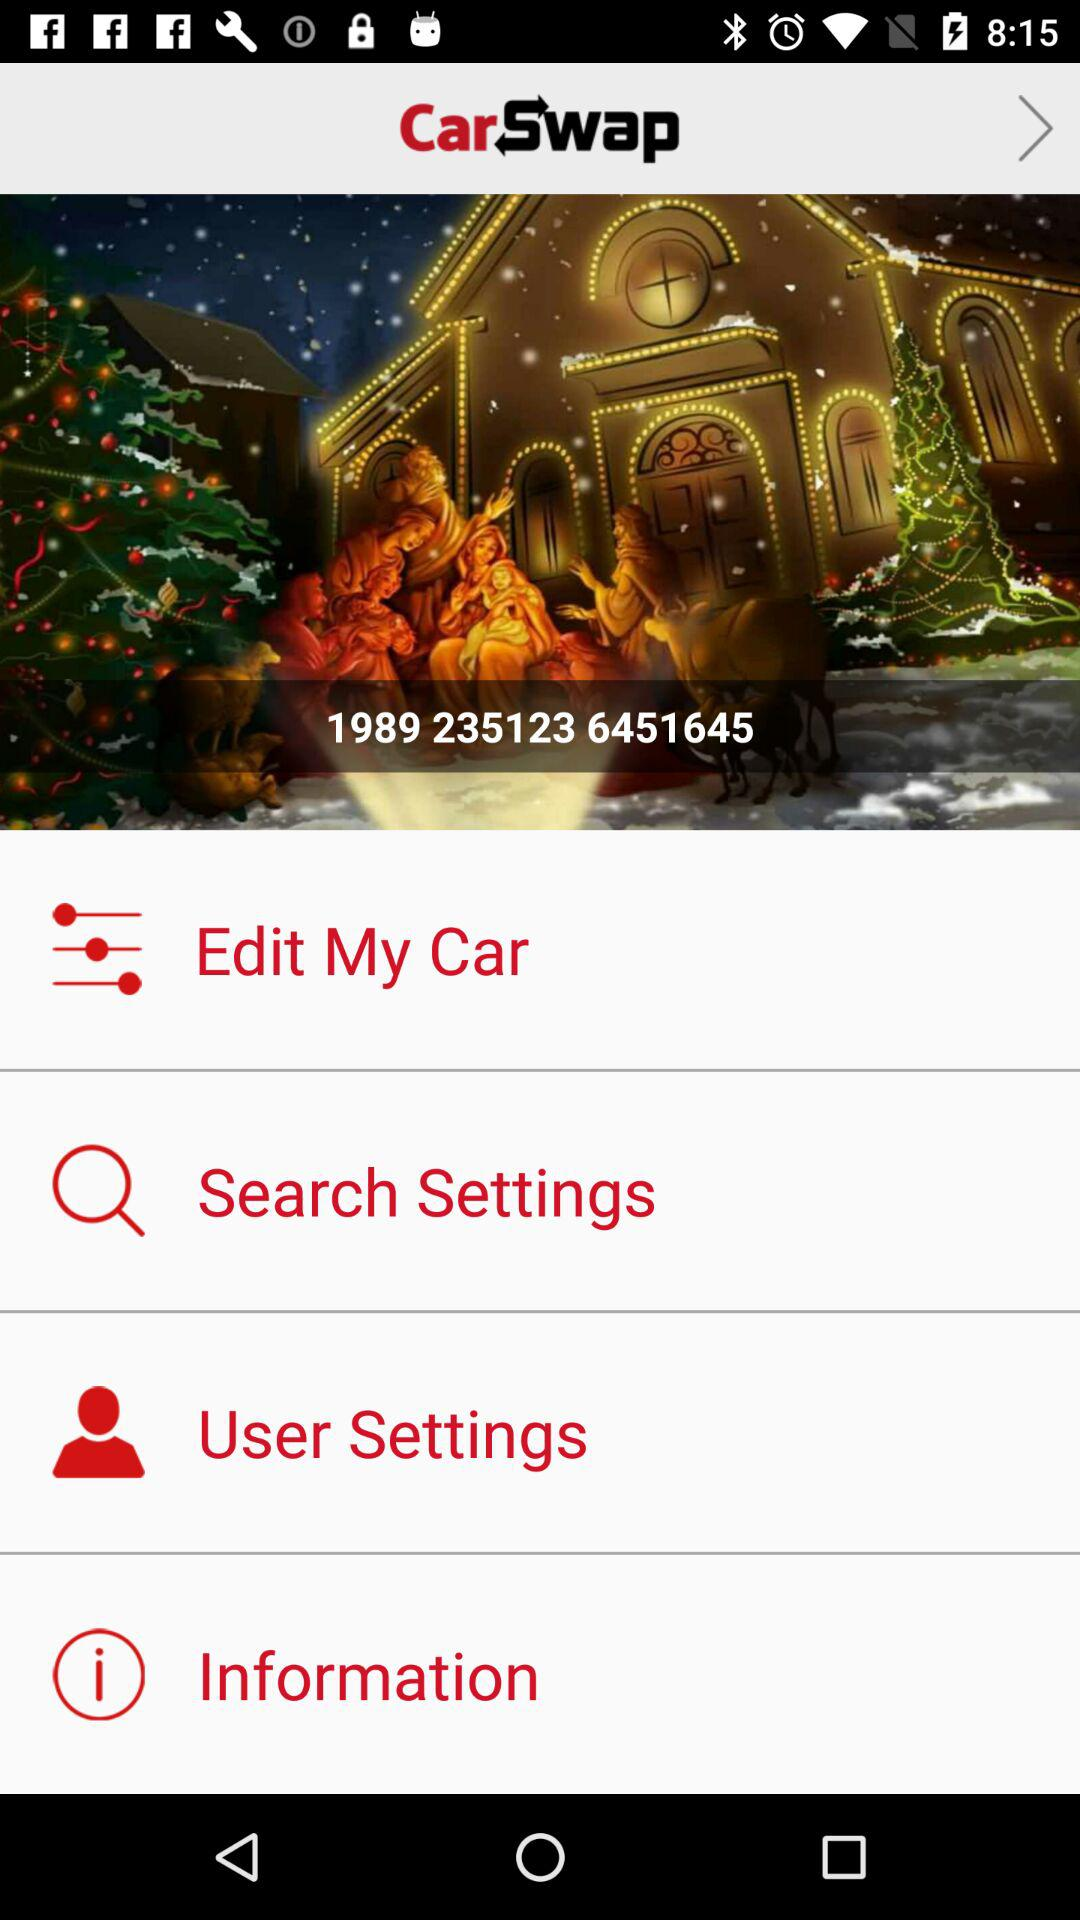What is the application name? The application name is "CarSwap". 